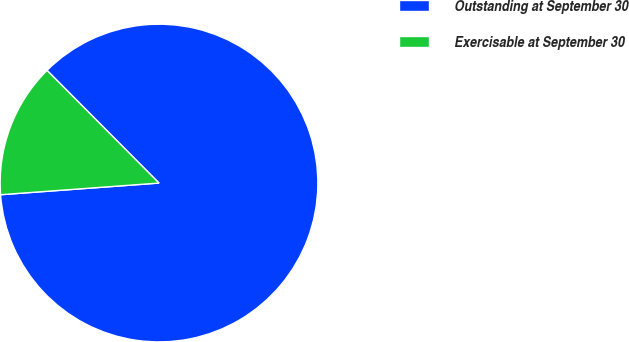Convert chart to OTSL. <chart><loc_0><loc_0><loc_500><loc_500><pie_chart><fcel>Outstanding at September 30<fcel>Exercisable at September 30<nl><fcel>86.28%<fcel>13.72%<nl></chart> 